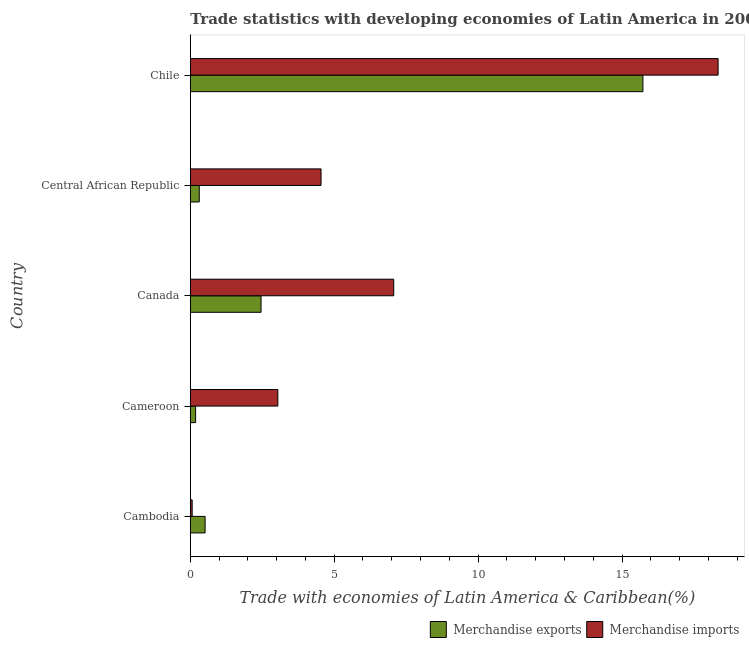How many different coloured bars are there?
Your response must be concise. 2. Are the number of bars on each tick of the Y-axis equal?
Provide a short and direct response. Yes. How many bars are there on the 2nd tick from the top?
Your answer should be compact. 2. How many bars are there on the 4th tick from the bottom?
Your answer should be compact. 2. What is the label of the 4th group of bars from the top?
Your response must be concise. Cameroon. In how many cases, is the number of bars for a given country not equal to the number of legend labels?
Provide a short and direct response. 0. What is the merchandise exports in Canada?
Your response must be concise. 2.46. Across all countries, what is the maximum merchandise imports?
Keep it short and to the point. 18.34. Across all countries, what is the minimum merchandise imports?
Provide a succinct answer. 0.06. In which country was the merchandise imports maximum?
Your answer should be compact. Chile. In which country was the merchandise exports minimum?
Provide a short and direct response. Cameroon. What is the total merchandise imports in the graph?
Keep it short and to the point. 33.05. What is the difference between the merchandise imports in Canada and that in Chile?
Your answer should be compact. -11.27. What is the difference between the merchandise exports in Cambodia and the merchandise imports in Chile?
Provide a short and direct response. -17.82. What is the average merchandise imports per country?
Keep it short and to the point. 6.61. What is the difference between the merchandise exports and merchandise imports in Chile?
Offer a very short reply. -2.61. What is the ratio of the merchandise exports in Canada to that in Chile?
Provide a short and direct response. 0.16. Is the difference between the merchandise exports in Cambodia and Central African Republic greater than the difference between the merchandise imports in Cambodia and Central African Republic?
Ensure brevity in your answer.  Yes. What is the difference between the highest and the second highest merchandise imports?
Ensure brevity in your answer.  11.27. What is the difference between the highest and the lowest merchandise exports?
Provide a succinct answer. 15.54. Is the sum of the merchandise imports in Cambodia and Central African Republic greater than the maximum merchandise exports across all countries?
Your answer should be compact. No. What does the 2nd bar from the bottom in Canada represents?
Your answer should be compact. Merchandise imports. How many bars are there?
Make the answer very short. 10. How many countries are there in the graph?
Offer a terse response. 5. Are the values on the major ticks of X-axis written in scientific E-notation?
Ensure brevity in your answer.  No. Where does the legend appear in the graph?
Ensure brevity in your answer.  Bottom right. How many legend labels are there?
Provide a short and direct response. 2. What is the title of the graph?
Your response must be concise. Trade statistics with developing economies of Latin America in 2009. What is the label or title of the X-axis?
Your answer should be compact. Trade with economies of Latin America & Caribbean(%). What is the label or title of the Y-axis?
Make the answer very short. Country. What is the Trade with economies of Latin America & Caribbean(%) of Merchandise exports in Cambodia?
Provide a succinct answer. 0.51. What is the Trade with economies of Latin America & Caribbean(%) in Merchandise imports in Cambodia?
Give a very brief answer. 0.06. What is the Trade with economies of Latin America & Caribbean(%) of Merchandise exports in Cameroon?
Offer a very short reply. 0.18. What is the Trade with economies of Latin America & Caribbean(%) of Merchandise imports in Cameroon?
Offer a terse response. 3.04. What is the Trade with economies of Latin America & Caribbean(%) of Merchandise exports in Canada?
Offer a very short reply. 2.46. What is the Trade with economies of Latin America & Caribbean(%) in Merchandise imports in Canada?
Offer a terse response. 7.07. What is the Trade with economies of Latin America & Caribbean(%) in Merchandise exports in Central African Republic?
Provide a succinct answer. 0.31. What is the Trade with economies of Latin America & Caribbean(%) of Merchandise imports in Central African Republic?
Provide a succinct answer. 4.54. What is the Trade with economies of Latin America & Caribbean(%) of Merchandise exports in Chile?
Your answer should be compact. 15.72. What is the Trade with economies of Latin America & Caribbean(%) in Merchandise imports in Chile?
Give a very brief answer. 18.34. Across all countries, what is the maximum Trade with economies of Latin America & Caribbean(%) of Merchandise exports?
Your answer should be compact. 15.72. Across all countries, what is the maximum Trade with economies of Latin America & Caribbean(%) of Merchandise imports?
Provide a succinct answer. 18.34. Across all countries, what is the minimum Trade with economies of Latin America & Caribbean(%) of Merchandise exports?
Ensure brevity in your answer.  0.18. Across all countries, what is the minimum Trade with economies of Latin America & Caribbean(%) of Merchandise imports?
Ensure brevity in your answer.  0.06. What is the total Trade with economies of Latin America & Caribbean(%) in Merchandise exports in the graph?
Your answer should be compact. 19.19. What is the total Trade with economies of Latin America & Caribbean(%) in Merchandise imports in the graph?
Your answer should be compact. 33.05. What is the difference between the Trade with economies of Latin America & Caribbean(%) of Merchandise exports in Cambodia and that in Cameroon?
Your answer should be compact. 0.33. What is the difference between the Trade with economies of Latin America & Caribbean(%) of Merchandise imports in Cambodia and that in Cameroon?
Offer a very short reply. -2.98. What is the difference between the Trade with economies of Latin America & Caribbean(%) in Merchandise exports in Cambodia and that in Canada?
Provide a succinct answer. -1.94. What is the difference between the Trade with economies of Latin America & Caribbean(%) in Merchandise imports in Cambodia and that in Canada?
Your response must be concise. -7. What is the difference between the Trade with economies of Latin America & Caribbean(%) in Merchandise exports in Cambodia and that in Central African Republic?
Provide a short and direct response. 0.2. What is the difference between the Trade with economies of Latin America & Caribbean(%) of Merchandise imports in Cambodia and that in Central African Republic?
Your answer should be very brief. -4.48. What is the difference between the Trade with economies of Latin America & Caribbean(%) of Merchandise exports in Cambodia and that in Chile?
Your answer should be very brief. -15.21. What is the difference between the Trade with economies of Latin America & Caribbean(%) of Merchandise imports in Cambodia and that in Chile?
Offer a very short reply. -18.27. What is the difference between the Trade with economies of Latin America & Caribbean(%) of Merchandise exports in Cameroon and that in Canada?
Offer a very short reply. -2.27. What is the difference between the Trade with economies of Latin America & Caribbean(%) of Merchandise imports in Cameroon and that in Canada?
Your answer should be very brief. -4.03. What is the difference between the Trade with economies of Latin America & Caribbean(%) of Merchandise exports in Cameroon and that in Central African Republic?
Offer a very short reply. -0.13. What is the difference between the Trade with economies of Latin America & Caribbean(%) in Merchandise imports in Cameroon and that in Central African Republic?
Ensure brevity in your answer.  -1.5. What is the difference between the Trade with economies of Latin America & Caribbean(%) of Merchandise exports in Cameroon and that in Chile?
Your response must be concise. -15.54. What is the difference between the Trade with economies of Latin America & Caribbean(%) in Merchandise imports in Cameroon and that in Chile?
Offer a very short reply. -15.3. What is the difference between the Trade with economies of Latin America & Caribbean(%) of Merchandise exports in Canada and that in Central African Republic?
Give a very brief answer. 2.15. What is the difference between the Trade with economies of Latin America & Caribbean(%) of Merchandise imports in Canada and that in Central African Republic?
Keep it short and to the point. 2.53. What is the difference between the Trade with economies of Latin America & Caribbean(%) of Merchandise exports in Canada and that in Chile?
Offer a terse response. -13.27. What is the difference between the Trade with economies of Latin America & Caribbean(%) in Merchandise imports in Canada and that in Chile?
Your answer should be very brief. -11.27. What is the difference between the Trade with economies of Latin America & Caribbean(%) in Merchandise exports in Central African Republic and that in Chile?
Offer a very short reply. -15.41. What is the difference between the Trade with economies of Latin America & Caribbean(%) of Merchandise imports in Central African Republic and that in Chile?
Offer a terse response. -13.79. What is the difference between the Trade with economies of Latin America & Caribbean(%) of Merchandise exports in Cambodia and the Trade with economies of Latin America & Caribbean(%) of Merchandise imports in Cameroon?
Provide a short and direct response. -2.53. What is the difference between the Trade with economies of Latin America & Caribbean(%) of Merchandise exports in Cambodia and the Trade with economies of Latin America & Caribbean(%) of Merchandise imports in Canada?
Provide a short and direct response. -6.55. What is the difference between the Trade with economies of Latin America & Caribbean(%) of Merchandise exports in Cambodia and the Trade with economies of Latin America & Caribbean(%) of Merchandise imports in Central African Republic?
Your response must be concise. -4.03. What is the difference between the Trade with economies of Latin America & Caribbean(%) of Merchandise exports in Cambodia and the Trade with economies of Latin America & Caribbean(%) of Merchandise imports in Chile?
Your response must be concise. -17.82. What is the difference between the Trade with economies of Latin America & Caribbean(%) in Merchandise exports in Cameroon and the Trade with economies of Latin America & Caribbean(%) in Merchandise imports in Canada?
Give a very brief answer. -6.88. What is the difference between the Trade with economies of Latin America & Caribbean(%) in Merchandise exports in Cameroon and the Trade with economies of Latin America & Caribbean(%) in Merchandise imports in Central African Republic?
Ensure brevity in your answer.  -4.36. What is the difference between the Trade with economies of Latin America & Caribbean(%) in Merchandise exports in Cameroon and the Trade with economies of Latin America & Caribbean(%) in Merchandise imports in Chile?
Provide a short and direct response. -18.15. What is the difference between the Trade with economies of Latin America & Caribbean(%) of Merchandise exports in Canada and the Trade with economies of Latin America & Caribbean(%) of Merchandise imports in Central African Republic?
Provide a short and direct response. -2.08. What is the difference between the Trade with economies of Latin America & Caribbean(%) of Merchandise exports in Canada and the Trade with economies of Latin America & Caribbean(%) of Merchandise imports in Chile?
Provide a short and direct response. -15.88. What is the difference between the Trade with economies of Latin America & Caribbean(%) of Merchandise exports in Central African Republic and the Trade with economies of Latin America & Caribbean(%) of Merchandise imports in Chile?
Give a very brief answer. -18.03. What is the average Trade with economies of Latin America & Caribbean(%) of Merchandise exports per country?
Provide a short and direct response. 3.84. What is the average Trade with economies of Latin America & Caribbean(%) in Merchandise imports per country?
Your answer should be compact. 6.61. What is the difference between the Trade with economies of Latin America & Caribbean(%) in Merchandise exports and Trade with economies of Latin America & Caribbean(%) in Merchandise imports in Cambodia?
Your answer should be very brief. 0.45. What is the difference between the Trade with economies of Latin America & Caribbean(%) of Merchandise exports and Trade with economies of Latin America & Caribbean(%) of Merchandise imports in Cameroon?
Give a very brief answer. -2.86. What is the difference between the Trade with economies of Latin America & Caribbean(%) of Merchandise exports and Trade with economies of Latin America & Caribbean(%) of Merchandise imports in Canada?
Your answer should be compact. -4.61. What is the difference between the Trade with economies of Latin America & Caribbean(%) in Merchandise exports and Trade with economies of Latin America & Caribbean(%) in Merchandise imports in Central African Republic?
Give a very brief answer. -4.23. What is the difference between the Trade with economies of Latin America & Caribbean(%) of Merchandise exports and Trade with economies of Latin America & Caribbean(%) of Merchandise imports in Chile?
Provide a succinct answer. -2.61. What is the ratio of the Trade with economies of Latin America & Caribbean(%) in Merchandise exports in Cambodia to that in Cameroon?
Your answer should be very brief. 2.78. What is the ratio of the Trade with economies of Latin America & Caribbean(%) in Merchandise imports in Cambodia to that in Cameroon?
Make the answer very short. 0.02. What is the ratio of the Trade with economies of Latin America & Caribbean(%) in Merchandise exports in Cambodia to that in Canada?
Your answer should be compact. 0.21. What is the ratio of the Trade with economies of Latin America & Caribbean(%) in Merchandise imports in Cambodia to that in Canada?
Make the answer very short. 0.01. What is the ratio of the Trade with economies of Latin America & Caribbean(%) in Merchandise exports in Cambodia to that in Central African Republic?
Give a very brief answer. 1.65. What is the ratio of the Trade with economies of Latin America & Caribbean(%) in Merchandise imports in Cambodia to that in Central African Republic?
Your response must be concise. 0.01. What is the ratio of the Trade with economies of Latin America & Caribbean(%) in Merchandise exports in Cambodia to that in Chile?
Your response must be concise. 0.03. What is the ratio of the Trade with economies of Latin America & Caribbean(%) in Merchandise imports in Cambodia to that in Chile?
Provide a short and direct response. 0. What is the ratio of the Trade with economies of Latin America & Caribbean(%) of Merchandise exports in Cameroon to that in Canada?
Provide a succinct answer. 0.08. What is the ratio of the Trade with economies of Latin America & Caribbean(%) in Merchandise imports in Cameroon to that in Canada?
Keep it short and to the point. 0.43. What is the ratio of the Trade with economies of Latin America & Caribbean(%) of Merchandise exports in Cameroon to that in Central African Republic?
Give a very brief answer. 0.59. What is the ratio of the Trade with economies of Latin America & Caribbean(%) of Merchandise imports in Cameroon to that in Central African Republic?
Your answer should be very brief. 0.67. What is the ratio of the Trade with economies of Latin America & Caribbean(%) in Merchandise exports in Cameroon to that in Chile?
Your answer should be compact. 0.01. What is the ratio of the Trade with economies of Latin America & Caribbean(%) in Merchandise imports in Cameroon to that in Chile?
Your answer should be very brief. 0.17. What is the ratio of the Trade with economies of Latin America & Caribbean(%) in Merchandise exports in Canada to that in Central African Republic?
Your answer should be very brief. 7.88. What is the ratio of the Trade with economies of Latin America & Caribbean(%) in Merchandise imports in Canada to that in Central African Republic?
Give a very brief answer. 1.56. What is the ratio of the Trade with economies of Latin America & Caribbean(%) of Merchandise exports in Canada to that in Chile?
Your answer should be compact. 0.16. What is the ratio of the Trade with economies of Latin America & Caribbean(%) of Merchandise imports in Canada to that in Chile?
Provide a short and direct response. 0.39. What is the ratio of the Trade with economies of Latin America & Caribbean(%) of Merchandise exports in Central African Republic to that in Chile?
Ensure brevity in your answer.  0.02. What is the ratio of the Trade with economies of Latin America & Caribbean(%) in Merchandise imports in Central African Republic to that in Chile?
Offer a very short reply. 0.25. What is the difference between the highest and the second highest Trade with economies of Latin America & Caribbean(%) in Merchandise exports?
Provide a succinct answer. 13.27. What is the difference between the highest and the second highest Trade with economies of Latin America & Caribbean(%) in Merchandise imports?
Make the answer very short. 11.27. What is the difference between the highest and the lowest Trade with economies of Latin America & Caribbean(%) of Merchandise exports?
Make the answer very short. 15.54. What is the difference between the highest and the lowest Trade with economies of Latin America & Caribbean(%) of Merchandise imports?
Provide a succinct answer. 18.27. 